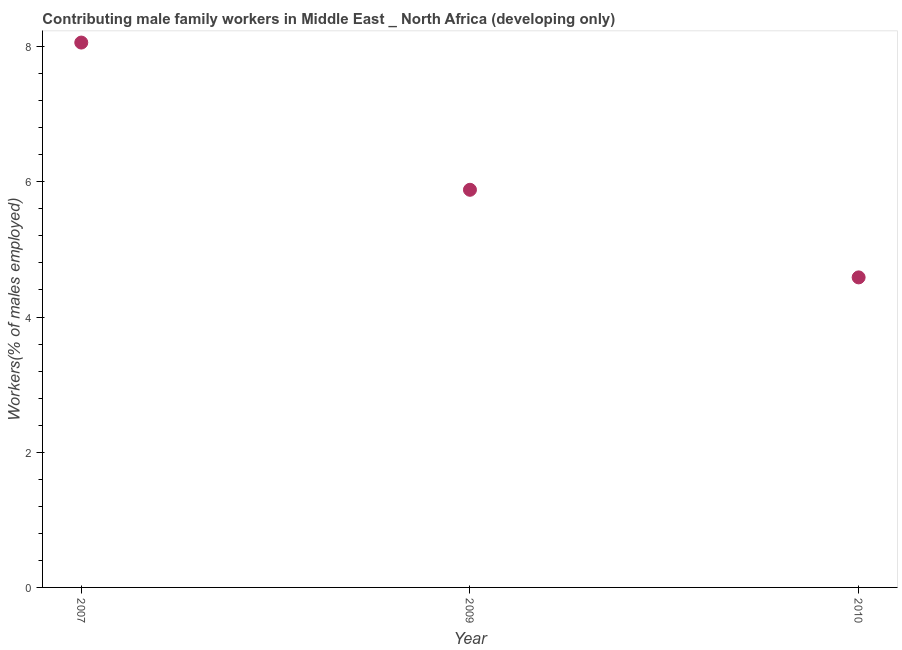What is the contributing male family workers in 2007?
Give a very brief answer. 8.06. Across all years, what is the maximum contributing male family workers?
Your response must be concise. 8.06. Across all years, what is the minimum contributing male family workers?
Provide a short and direct response. 4.59. In which year was the contributing male family workers maximum?
Offer a very short reply. 2007. What is the sum of the contributing male family workers?
Your answer should be compact. 18.53. What is the difference between the contributing male family workers in 2009 and 2010?
Ensure brevity in your answer.  1.3. What is the average contributing male family workers per year?
Offer a very short reply. 6.18. What is the median contributing male family workers?
Your answer should be compact. 5.88. In how many years, is the contributing male family workers greater than 3.6 %?
Give a very brief answer. 3. Do a majority of the years between 2009 and 2007 (inclusive) have contributing male family workers greater than 6.8 %?
Make the answer very short. No. What is the ratio of the contributing male family workers in 2009 to that in 2010?
Provide a short and direct response. 1.28. Is the contributing male family workers in 2007 less than that in 2009?
Keep it short and to the point. No. What is the difference between the highest and the second highest contributing male family workers?
Your answer should be very brief. 2.18. What is the difference between the highest and the lowest contributing male family workers?
Your response must be concise. 3.47. How many years are there in the graph?
Your answer should be very brief. 3. What is the difference between two consecutive major ticks on the Y-axis?
Your response must be concise. 2. Are the values on the major ticks of Y-axis written in scientific E-notation?
Make the answer very short. No. Does the graph contain any zero values?
Keep it short and to the point. No. What is the title of the graph?
Make the answer very short. Contributing male family workers in Middle East _ North Africa (developing only). What is the label or title of the Y-axis?
Provide a short and direct response. Workers(% of males employed). What is the Workers(% of males employed) in 2007?
Your answer should be compact. 8.06. What is the Workers(% of males employed) in 2009?
Your answer should be very brief. 5.88. What is the Workers(% of males employed) in 2010?
Offer a very short reply. 4.59. What is the difference between the Workers(% of males employed) in 2007 and 2009?
Your response must be concise. 2.18. What is the difference between the Workers(% of males employed) in 2007 and 2010?
Your answer should be very brief. 3.47. What is the difference between the Workers(% of males employed) in 2009 and 2010?
Your answer should be compact. 1.3. What is the ratio of the Workers(% of males employed) in 2007 to that in 2009?
Offer a very short reply. 1.37. What is the ratio of the Workers(% of males employed) in 2007 to that in 2010?
Your answer should be very brief. 1.76. What is the ratio of the Workers(% of males employed) in 2009 to that in 2010?
Your response must be concise. 1.28. 